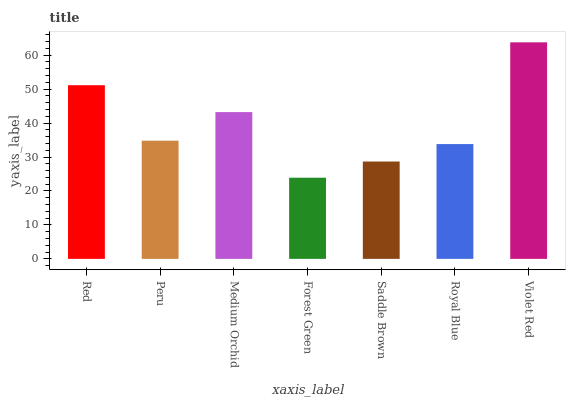Is Forest Green the minimum?
Answer yes or no. Yes. Is Violet Red the maximum?
Answer yes or no. Yes. Is Peru the minimum?
Answer yes or no. No. Is Peru the maximum?
Answer yes or no. No. Is Red greater than Peru?
Answer yes or no. Yes. Is Peru less than Red?
Answer yes or no. Yes. Is Peru greater than Red?
Answer yes or no. No. Is Red less than Peru?
Answer yes or no. No. Is Peru the high median?
Answer yes or no. Yes. Is Peru the low median?
Answer yes or no. Yes. Is Violet Red the high median?
Answer yes or no. No. Is Saddle Brown the low median?
Answer yes or no. No. 